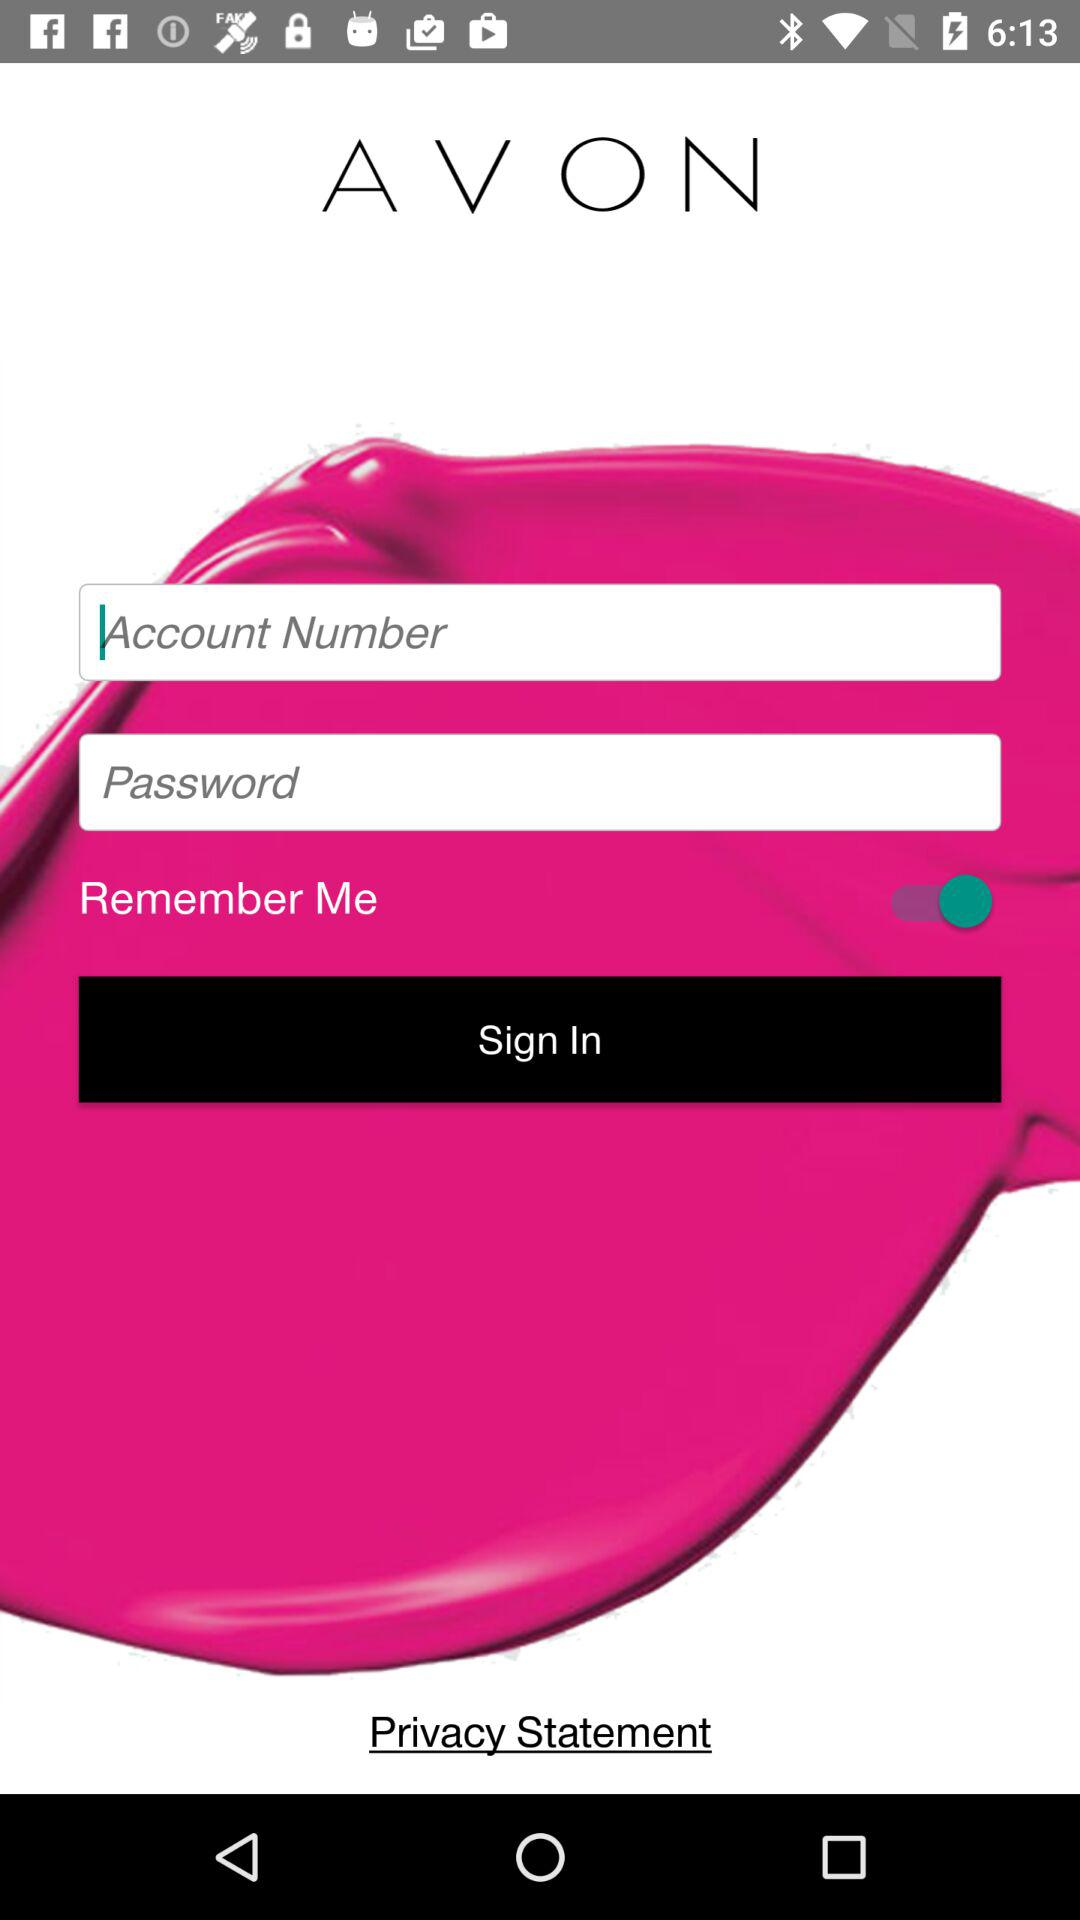What is the application name? The application name is "AVON". 